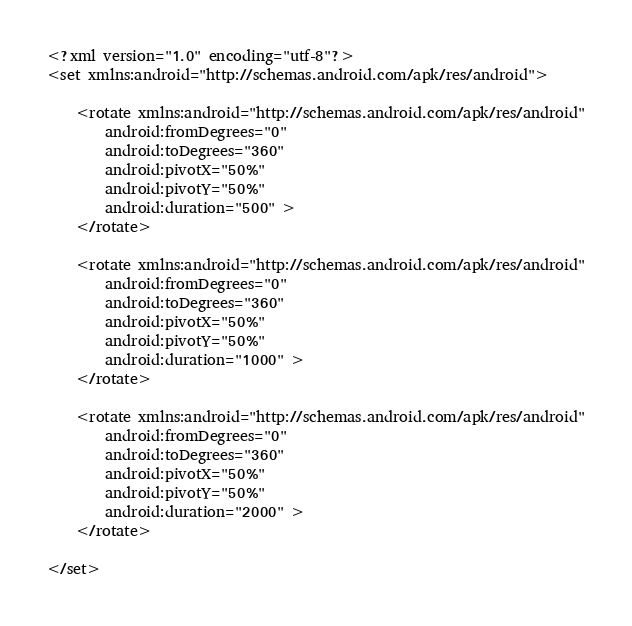Convert code to text. <code><loc_0><loc_0><loc_500><loc_500><_XML_><?xml version="1.0" encoding="utf-8"?>
<set xmlns:android="http://schemas.android.com/apk/res/android">

    <rotate xmlns:android="http://schemas.android.com/apk/res/android"
        android:fromDegrees="0"
        android:toDegrees="360"
        android:pivotX="50%"
        android:pivotY="50%"
        android:duration="500" >
    </rotate>

    <rotate xmlns:android="http://schemas.android.com/apk/res/android"
        android:fromDegrees="0"
        android:toDegrees="360"
        android:pivotX="50%"
        android:pivotY="50%"
        android:duration="1000" >
    </rotate>

    <rotate xmlns:android="http://schemas.android.com/apk/res/android"
        android:fromDegrees="0"
        android:toDegrees="360"
        android:pivotX="50%"
        android:pivotY="50%"
        android:duration="2000" >
    </rotate>

</set></code> 